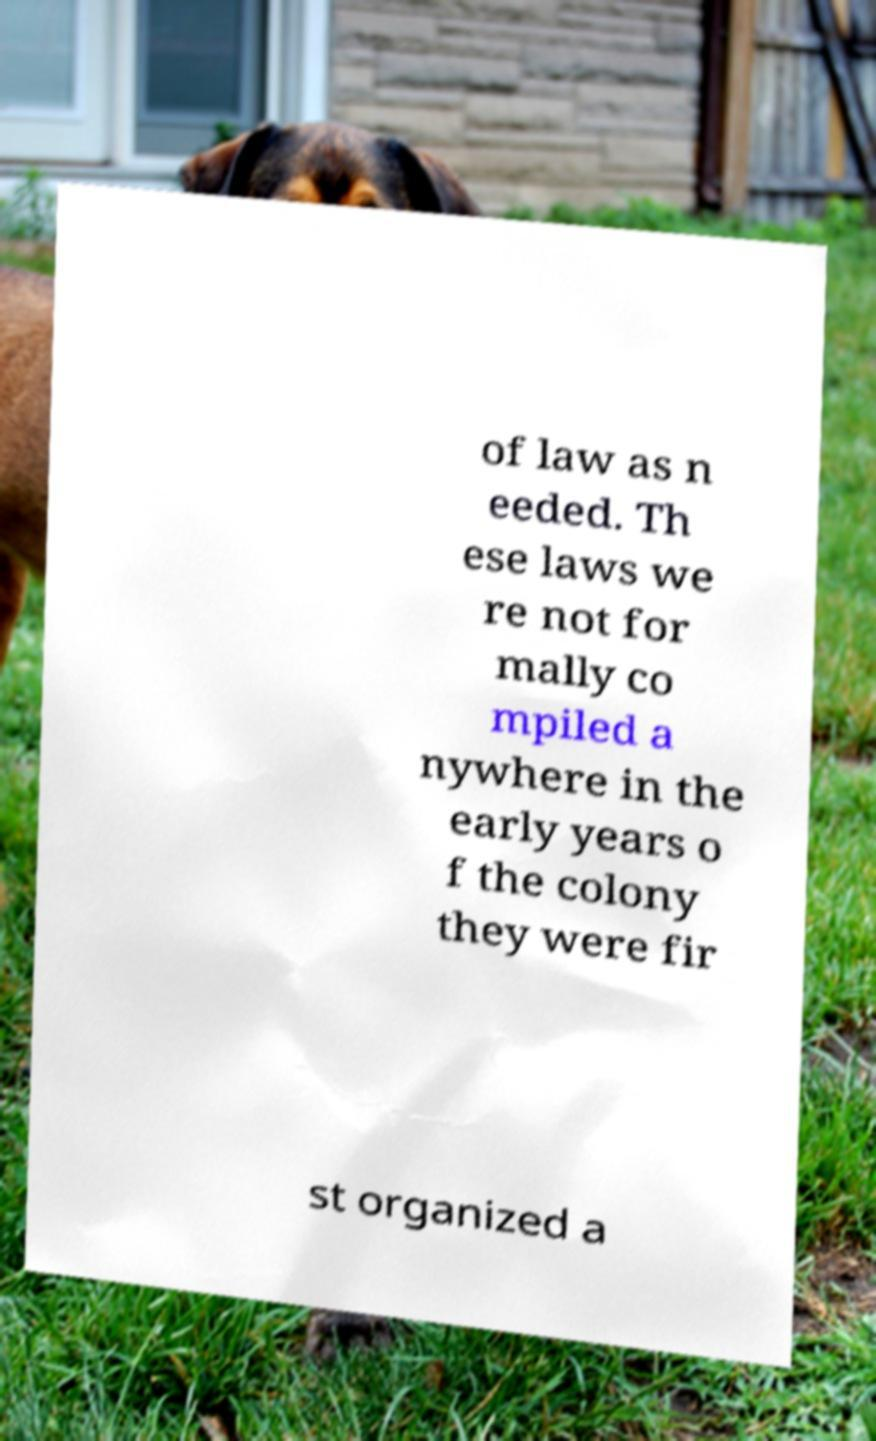Can you read and provide the text displayed in the image?This photo seems to have some interesting text. Can you extract and type it out for me? of law as n eeded. Th ese laws we re not for mally co mpiled a nywhere in the early years o f the colony they were fir st organized a 